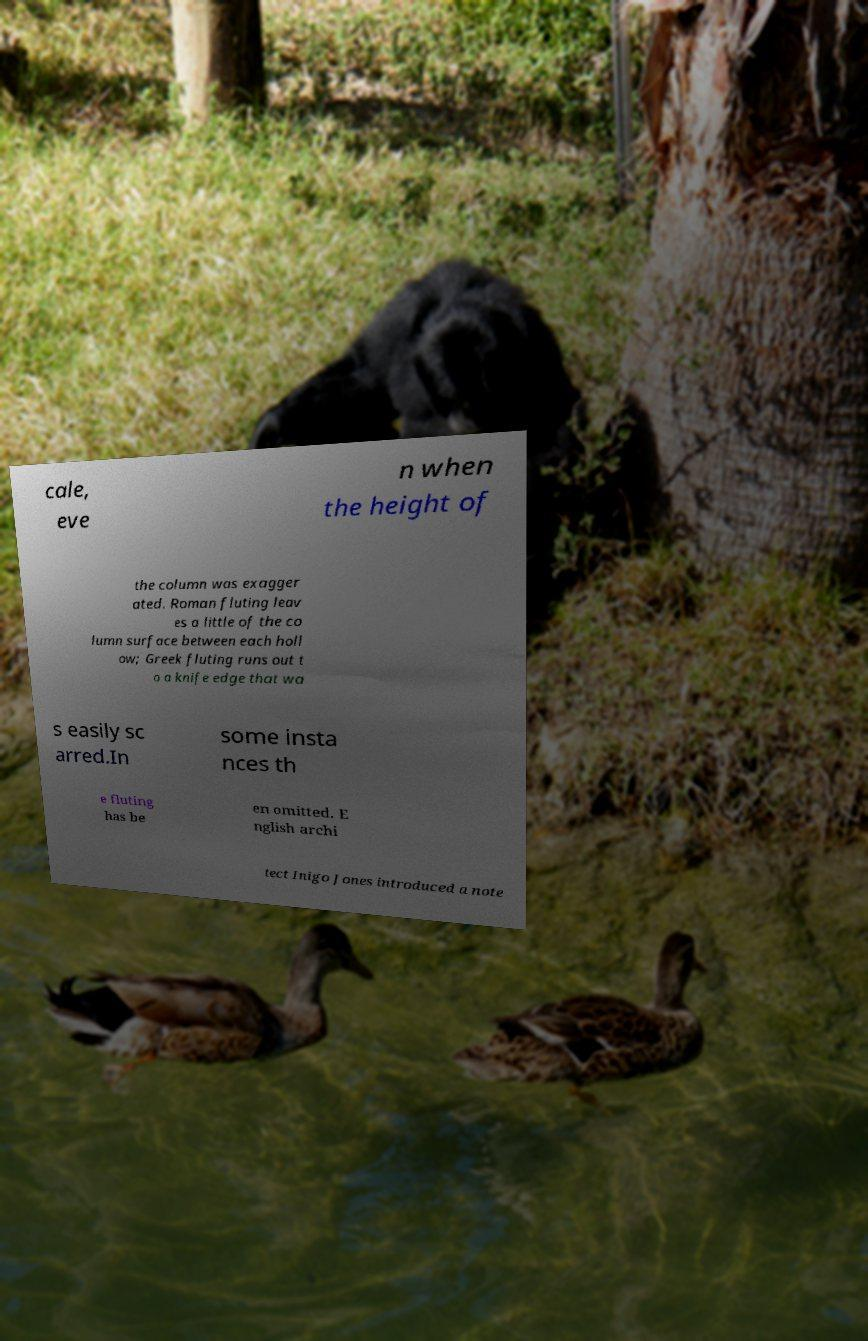Please identify and transcribe the text found in this image. cale, eve n when the height of the column was exagger ated. Roman fluting leav es a little of the co lumn surface between each holl ow; Greek fluting runs out t o a knife edge that wa s easily sc arred.In some insta nces th e fluting has be en omitted. E nglish archi tect Inigo Jones introduced a note 